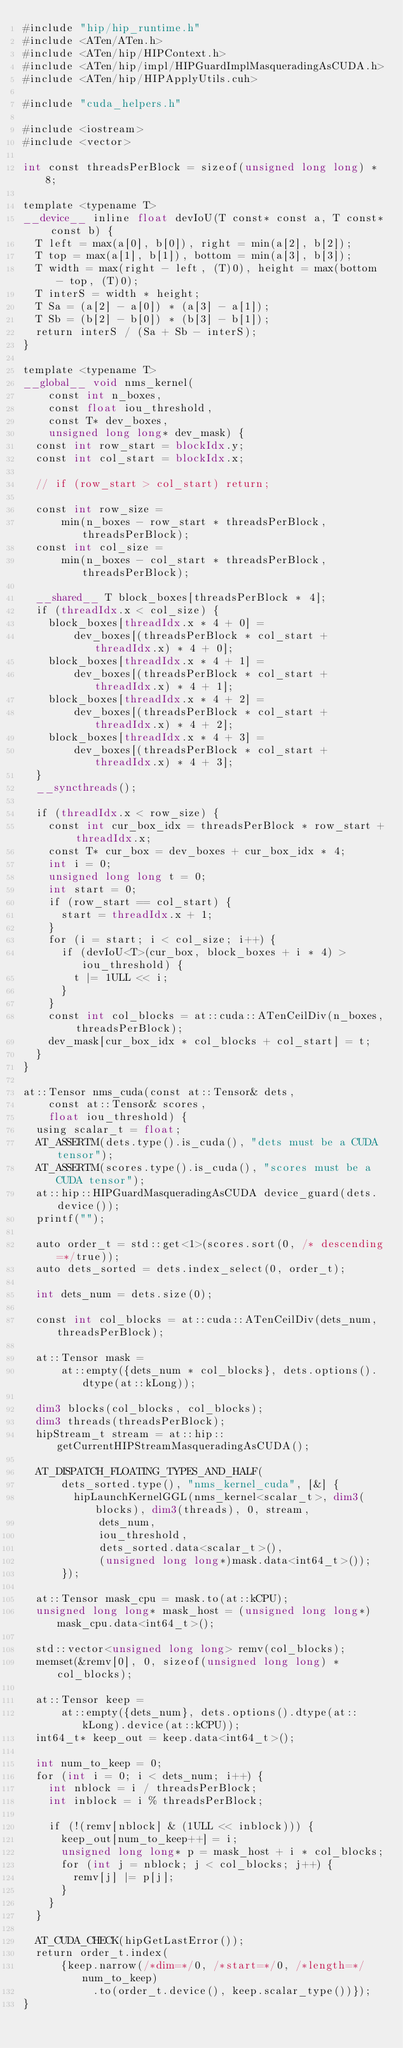<code> <loc_0><loc_0><loc_500><loc_500><_Cuda_>#include "hip/hip_runtime.h"
#include <ATen/ATen.h>
#include <ATen/hip/HIPContext.h>
#include <ATen/hip/impl/HIPGuardImplMasqueradingAsCUDA.h>
#include <ATen/hip/HIPApplyUtils.cuh>

#include "cuda_helpers.h"

#include <iostream>
#include <vector>

int const threadsPerBlock = sizeof(unsigned long long) * 8;

template <typename T>
__device__ inline float devIoU(T const* const a, T const* const b) {
  T left = max(a[0], b[0]), right = min(a[2], b[2]);
  T top = max(a[1], b[1]), bottom = min(a[3], b[3]);
  T width = max(right - left, (T)0), height = max(bottom - top, (T)0);
  T interS = width * height;
  T Sa = (a[2] - a[0]) * (a[3] - a[1]);
  T Sb = (b[2] - b[0]) * (b[3] - b[1]);
  return interS / (Sa + Sb - interS);
}

template <typename T>
__global__ void nms_kernel(
    const int n_boxes,
    const float iou_threshold,
    const T* dev_boxes,
    unsigned long long* dev_mask) {
  const int row_start = blockIdx.y;
  const int col_start = blockIdx.x;

  // if (row_start > col_start) return;

  const int row_size =
      min(n_boxes - row_start * threadsPerBlock, threadsPerBlock);
  const int col_size =
      min(n_boxes - col_start * threadsPerBlock, threadsPerBlock);

  __shared__ T block_boxes[threadsPerBlock * 4];
  if (threadIdx.x < col_size) {
    block_boxes[threadIdx.x * 4 + 0] =
        dev_boxes[(threadsPerBlock * col_start + threadIdx.x) * 4 + 0];
    block_boxes[threadIdx.x * 4 + 1] =
        dev_boxes[(threadsPerBlock * col_start + threadIdx.x) * 4 + 1];
    block_boxes[threadIdx.x * 4 + 2] =
        dev_boxes[(threadsPerBlock * col_start + threadIdx.x) * 4 + 2];
    block_boxes[threadIdx.x * 4 + 3] =
        dev_boxes[(threadsPerBlock * col_start + threadIdx.x) * 4 + 3];
  }
  __syncthreads();

  if (threadIdx.x < row_size) {
    const int cur_box_idx = threadsPerBlock * row_start + threadIdx.x;
    const T* cur_box = dev_boxes + cur_box_idx * 4;
    int i = 0;
    unsigned long long t = 0;
    int start = 0;
    if (row_start == col_start) {
      start = threadIdx.x + 1;
    }
    for (i = start; i < col_size; i++) {
      if (devIoU<T>(cur_box, block_boxes + i * 4) > iou_threshold) {
        t |= 1ULL << i;
      }
    }
    const int col_blocks = at::cuda::ATenCeilDiv(n_boxes, threadsPerBlock);
    dev_mask[cur_box_idx * col_blocks + col_start] = t;
  }
}

at::Tensor nms_cuda(const at::Tensor& dets,
    const at::Tensor& scores,
    float iou_threshold) {
  using scalar_t = float;
  AT_ASSERTM(dets.type().is_cuda(), "dets must be a CUDA tensor");
  AT_ASSERTM(scores.type().is_cuda(), "scores must be a CUDA tensor");
  at::hip::HIPGuardMasqueradingAsCUDA device_guard(dets.device());
  printf("");

  auto order_t = std::get<1>(scores.sort(0, /* descending=*/true));
  auto dets_sorted = dets.index_select(0, order_t);

  int dets_num = dets.size(0);

  const int col_blocks = at::cuda::ATenCeilDiv(dets_num, threadsPerBlock);

  at::Tensor mask =
      at::empty({dets_num * col_blocks}, dets.options().dtype(at::kLong));

  dim3 blocks(col_blocks, col_blocks);
  dim3 threads(threadsPerBlock);
  hipStream_t stream = at::hip::getCurrentHIPStreamMasqueradingAsCUDA();

  AT_DISPATCH_FLOATING_TYPES_AND_HALF(
      dets_sorted.type(), "nms_kernel_cuda", [&] {
        hipLaunchKernelGGL(nms_kernel<scalar_t>, dim3(blocks), dim3(threads), 0, stream, 
            dets_num,
            iou_threshold,
            dets_sorted.data<scalar_t>(),
            (unsigned long long*)mask.data<int64_t>());
      });

  at::Tensor mask_cpu = mask.to(at::kCPU);
  unsigned long long* mask_host = (unsigned long long*)mask_cpu.data<int64_t>();

  std::vector<unsigned long long> remv(col_blocks);
  memset(&remv[0], 0, sizeof(unsigned long long) * col_blocks);

  at::Tensor keep =
      at::empty({dets_num}, dets.options().dtype(at::kLong).device(at::kCPU));
  int64_t* keep_out = keep.data<int64_t>();

  int num_to_keep = 0;
  for (int i = 0; i < dets_num; i++) {
    int nblock = i / threadsPerBlock;
    int inblock = i % threadsPerBlock;

    if (!(remv[nblock] & (1ULL << inblock))) {
      keep_out[num_to_keep++] = i;
      unsigned long long* p = mask_host + i * col_blocks;
      for (int j = nblock; j < col_blocks; j++) {
        remv[j] |= p[j];
      }
    }
  }

  AT_CUDA_CHECK(hipGetLastError());
  return order_t.index(
      {keep.narrow(/*dim=*/0, /*start=*/0, /*length=*/num_to_keep)
           .to(order_t.device(), keep.scalar_type())});
}
</code> 